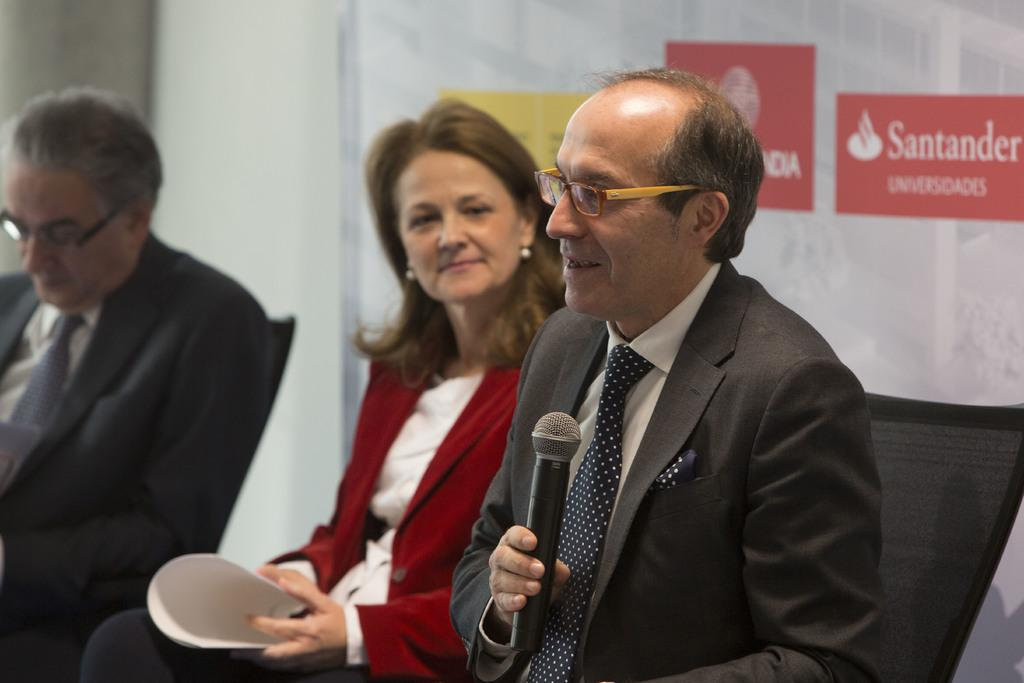How many people are seated in the image? There are three people seated on chairs in the image. What is the man holding in his hand? The man is holding a microphone in his hand. What is the man doing with the microphone? The man is speaking while holding the microphone. What is the woman holding in her hand? The woman is holding a paper in her hand. What is the woman doing while holding the paper? The woman is watching the man. Can you see any snails crawling on the chairs in the image? There are no snails present in the image. What type of quince is being served to the people in the image? There is no mention of quince or any food being served in the image. 